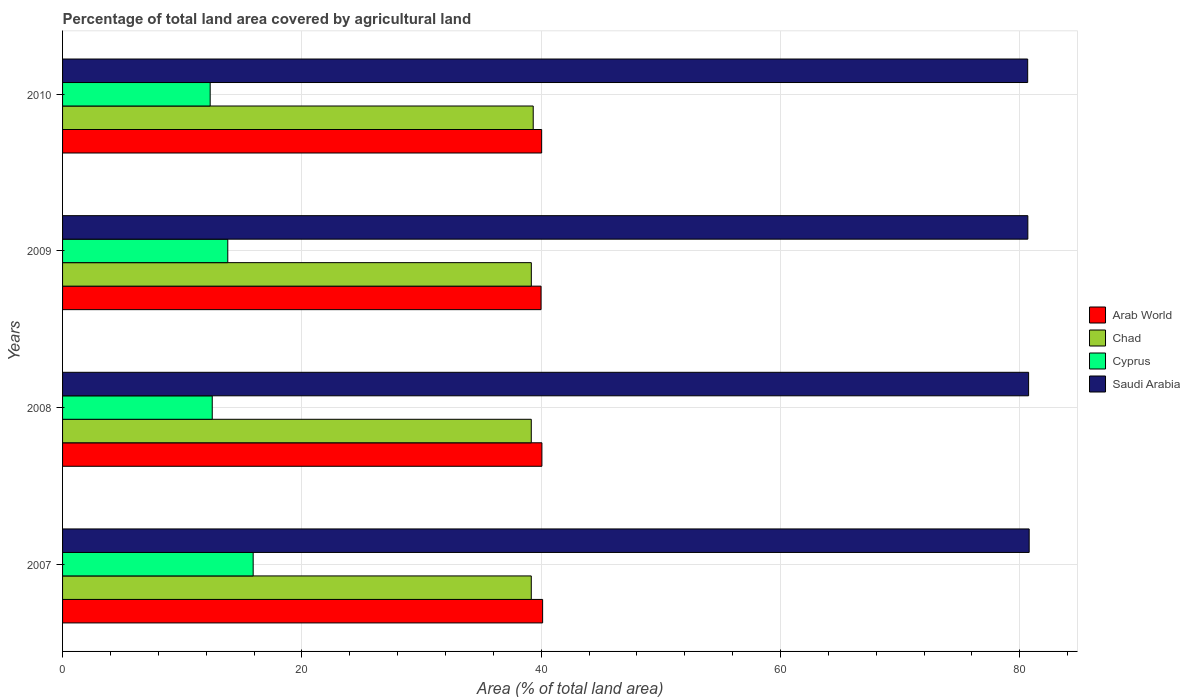How many groups of bars are there?
Give a very brief answer. 4. What is the label of the 3rd group of bars from the top?
Offer a terse response. 2008. What is the percentage of agricultural land in Cyprus in 2009?
Provide a short and direct response. 13.81. Across all years, what is the maximum percentage of agricultural land in Saudi Arabia?
Your answer should be compact. 80.79. Across all years, what is the minimum percentage of agricultural land in Saudi Arabia?
Offer a terse response. 80.67. What is the total percentage of agricultural land in Arab World in the graph?
Give a very brief answer. 160.22. What is the difference between the percentage of agricultural land in Cyprus in 2008 and that in 2010?
Ensure brevity in your answer.  0.17. What is the difference between the percentage of agricultural land in Chad in 2010 and the percentage of agricultural land in Cyprus in 2009?
Provide a succinct answer. 25.53. What is the average percentage of agricultural land in Cyprus per year?
Your answer should be very brief. 13.65. In the year 2007, what is the difference between the percentage of agricultural land in Cyprus and percentage of agricultural land in Saudi Arabia?
Make the answer very short. -64.86. What is the ratio of the percentage of agricultural land in Arab World in 2007 to that in 2009?
Offer a very short reply. 1. Is the percentage of agricultural land in Cyprus in 2007 less than that in 2010?
Ensure brevity in your answer.  No. What is the difference between the highest and the second highest percentage of agricultural land in Saudi Arabia?
Make the answer very short. 0.05. What is the difference between the highest and the lowest percentage of agricultural land in Arab World?
Provide a short and direct response. 0.13. In how many years, is the percentage of agricultural land in Saudi Arabia greater than the average percentage of agricultural land in Saudi Arabia taken over all years?
Give a very brief answer. 2. Is the sum of the percentage of agricultural land in Chad in 2009 and 2010 greater than the maximum percentage of agricultural land in Saudi Arabia across all years?
Give a very brief answer. No. What does the 1st bar from the top in 2007 represents?
Ensure brevity in your answer.  Saudi Arabia. What does the 3rd bar from the bottom in 2007 represents?
Your answer should be compact. Cyprus. Is it the case that in every year, the sum of the percentage of agricultural land in Cyprus and percentage of agricultural land in Chad is greater than the percentage of agricultural land in Saudi Arabia?
Your answer should be very brief. No. How many bars are there?
Your answer should be very brief. 16. Are all the bars in the graph horizontal?
Make the answer very short. Yes. How many legend labels are there?
Make the answer very short. 4. How are the legend labels stacked?
Your answer should be very brief. Vertical. What is the title of the graph?
Provide a succinct answer. Percentage of total land area covered by agricultural land. Does "Comoros" appear as one of the legend labels in the graph?
Your answer should be very brief. No. What is the label or title of the X-axis?
Your answer should be very brief. Area (% of total land area). What is the label or title of the Y-axis?
Make the answer very short. Years. What is the Area (% of total land area) of Arab World in 2007?
Make the answer very short. 40.12. What is the Area (% of total land area) of Chad in 2007?
Give a very brief answer. 39.18. What is the Area (% of total land area) of Cyprus in 2007?
Your answer should be very brief. 15.93. What is the Area (% of total land area) of Saudi Arabia in 2007?
Your response must be concise. 80.79. What is the Area (% of total land area) of Arab World in 2008?
Offer a terse response. 40.06. What is the Area (% of total land area) of Chad in 2008?
Your answer should be compact. 39.18. What is the Area (% of total land area) in Cyprus in 2008?
Give a very brief answer. 12.51. What is the Area (% of total land area) in Saudi Arabia in 2008?
Ensure brevity in your answer.  80.74. What is the Area (% of total land area) of Arab World in 2009?
Your answer should be compact. 39.99. What is the Area (% of total land area) in Chad in 2009?
Your answer should be very brief. 39.18. What is the Area (% of total land area) in Cyprus in 2009?
Your answer should be compact. 13.81. What is the Area (% of total land area) in Saudi Arabia in 2009?
Give a very brief answer. 80.68. What is the Area (% of total land area) of Arab World in 2010?
Your answer should be compact. 40.04. What is the Area (% of total land area) in Chad in 2010?
Give a very brief answer. 39.34. What is the Area (% of total land area) in Cyprus in 2010?
Keep it short and to the point. 12.34. What is the Area (% of total land area) of Saudi Arabia in 2010?
Your answer should be compact. 80.67. Across all years, what is the maximum Area (% of total land area) in Arab World?
Ensure brevity in your answer.  40.12. Across all years, what is the maximum Area (% of total land area) of Chad?
Give a very brief answer. 39.34. Across all years, what is the maximum Area (% of total land area) in Cyprus?
Make the answer very short. 15.93. Across all years, what is the maximum Area (% of total land area) of Saudi Arabia?
Your response must be concise. 80.79. Across all years, what is the minimum Area (% of total land area) of Arab World?
Make the answer very short. 39.99. Across all years, what is the minimum Area (% of total land area) in Chad?
Your answer should be very brief. 39.18. Across all years, what is the minimum Area (% of total land area) in Cyprus?
Provide a succinct answer. 12.34. Across all years, what is the minimum Area (% of total land area) in Saudi Arabia?
Make the answer very short. 80.67. What is the total Area (% of total land area) in Arab World in the graph?
Your response must be concise. 160.22. What is the total Area (% of total land area) in Chad in the graph?
Keep it short and to the point. 156.87. What is the total Area (% of total land area) in Cyprus in the graph?
Give a very brief answer. 54.59. What is the total Area (% of total land area) of Saudi Arabia in the graph?
Make the answer very short. 322.88. What is the difference between the Area (% of total land area) of Arab World in 2007 and that in 2008?
Your answer should be very brief. 0.06. What is the difference between the Area (% of total land area) of Cyprus in 2007 and that in 2008?
Make the answer very short. 3.42. What is the difference between the Area (% of total land area) in Saudi Arabia in 2007 and that in 2008?
Provide a succinct answer. 0.05. What is the difference between the Area (% of total land area) in Arab World in 2007 and that in 2009?
Provide a short and direct response. 0.13. What is the difference between the Area (% of total land area) in Chad in 2007 and that in 2009?
Keep it short and to the point. -0. What is the difference between the Area (% of total land area) in Cyprus in 2007 and that in 2009?
Offer a very short reply. 2.12. What is the difference between the Area (% of total land area) in Saudi Arabia in 2007 and that in 2009?
Provide a short and direct response. 0.11. What is the difference between the Area (% of total land area) of Arab World in 2007 and that in 2010?
Offer a terse response. 0.08. What is the difference between the Area (% of total land area) in Chad in 2007 and that in 2010?
Keep it short and to the point. -0.16. What is the difference between the Area (% of total land area) in Cyprus in 2007 and that in 2010?
Offer a very short reply. 3.59. What is the difference between the Area (% of total land area) in Saudi Arabia in 2007 and that in 2010?
Provide a short and direct response. 0.13. What is the difference between the Area (% of total land area) in Arab World in 2008 and that in 2009?
Offer a terse response. 0.07. What is the difference between the Area (% of total land area) in Chad in 2008 and that in 2009?
Your answer should be compact. -0. What is the difference between the Area (% of total land area) of Cyprus in 2008 and that in 2009?
Provide a short and direct response. -1.3. What is the difference between the Area (% of total land area) in Saudi Arabia in 2008 and that in 2009?
Make the answer very short. 0.06. What is the difference between the Area (% of total land area) of Arab World in 2008 and that in 2010?
Keep it short and to the point. 0.02. What is the difference between the Area (% of total land area) in Chad in 2008 and that in 2010?
Give a very brief answer. -0.16. What is the difference between the Area (% of total land area) in Cyprus in 2008 and that in 2010?
Keep it short and to the point. 0.17. What is the difference between the Area (% of total land area) in Saudi Arabia in 2008 and that in 2010?
Keep it short and to the point. 0.08. What is the difference between the Area (% of total land area) in Arab World in 2009 and that in 2010?
Ensure brevity in your answer.  -0.05. What is the difference between the Area (% of total land area) of Chad in 2009 and that in 2010?
Provide a short and direct response. -0.16. What is the difference between the Area (% of total land area) in Cyprus in 2009 and that in 2010?
Provide a short and direct response. 1.47. What is the difference between the Area (% of total land area) of Saudi Arabia in 2009 and that in 2010?
Offer a very short reply. 0.01. What is the difference between the Area (% of total land area) of Arab World in 2007 and the Area (% of total land area) of Chad in 2008?
Make the answer very short. 0.95. What is the difference between the Area (% of total land area) of Arab World in 2007 and the Area (% of total land area) of Cyprus in 2008?
Make the answer very short. 27.61. What is the difference between the Area (% of total land area) in Arab World in 2007 and the Area (% of total land area) in Saudi Arabia in 2008?
Keep it short and to the point. -40.62. What is the difference between the Area (% of total land area) in Chad in 2007 and the Area (% of total land area) in Cyprus in 2008?
Offer a very short reply. 26.67. What is the difference between the Area (% of total land area) in Chad in 2007 and the Area (% of total land area) in Saudi Arabia in 2008?
Your response must be concise. -41.57. What is the difference between the Area (% of total land area) of Cyprus in 2007 and the Area (% of total land area) of Saudi Arabia in 2008?
Your answer should be very brief. -64.81. What is the difference between the Area (% of total land area) of Arab World in 2007 and the Area (% of total land area) of Chad in 2009?
Provide a succinct answer. 0.94. What is the difference between the Area (% of total land area) in Arab World in 2007 and the Area (% of total land area) in Cyprus in 2009?
Your answer should be compact. 26.31. What is the difference between the Area (% of total land area) in Arab World in 2007 and the Area (% of total land area) in Saudi Arabia in 2009?
Your answer should be compact. -40.56. What is the difference between the Area (% of total land area) of Chad in 2007 and the Area (% of total land area) of Cyprus in 2009?
Your answer should be compact. 25.37. What is the difference between the Area (% of total land area) of Chad in 2007 and the Area (% of total land area) of Saudi Arabia in 2009?
Your answer should be compact. -41.5. What is the difference between the Area (% of total land area) in Cyprus in 2007 and the Area (% of total land area) in Saudi Arabia in 2009?
Keep it short and to the point. -64.75. What is the difference between the Area (% of total land area) in Arab World in 2007 and the Area (% of total land area) in Chad in 2010?
Your answer should be very brief. 0.79. What is the difference between the Area (% of total land area) of Arab World in 2007 and the Area (% of total land area) of Cyprus in 2010?
Provide a succinct answer. 27.79. What is the difference between the Area (% of total land area) of Arab World in 2007 and the Area (% of total land area) of Saudi Arabia in 2010?
Keep it short and to the point. -40.54. What is the difference between the Area (% of total land area) of Chad in 2007 and the Area (% of total land area) of Cyprus in 2010?
Offer a terse response. 26.84. What is the difference between the Area (% of total land area) of Chad in 2007 and the Area (% of total land area) of Saudi Arabia in 2010?
Keep it short and to the point. -41.49. What is the difference between the Area (% of total land area) of Cyprus in 2007 and the Area (% of total land area) of Saudi Arabia in 2010?
Your response must be concise. -64.73. What is the difference between the Area (% of total land area) in Arab World in 2008 and the Area (% of total land area) in Chad in 2009?
Ensure brevity in your answer.  0.88. What is the difference between the Area (% of total land area) of Arab World in 2008 and the Area (% of total land area) of Cyprus in 2009?
Your answer should be compact. 26.25. What is the difference between the Area (% of total land area) of Arab World in 2008 and the Area (% of total land area) of Saudi Arabia in 2009?
Keep it short and to the point. -40.62. What is the difference between the Area (% of total land area) in Chad in 2008 and the Area (% of total land area) in Cyprus in 2009?
Offer a terse response. 25.37. What is the difference between the Area (% of total land area) in Chad in 2008 and the Area (% of total land area) in Saudi Arabia in 2009?
Ensure brevity in your answer.  -41.5. What is the difference between the Area (% of total land area) of Cyprus in 2008 and the Area (% of total land area) of Saudi Arabia in 2009?
Your answer should be very brief. -68.17. What is the difference between the Area (% of total land area) of Arab World in 2008 and the Area (% of total land area) of Chad in 2010?
Your answer should be very brief. 0.72. What is the difference between the Area (% of total land area) in Arab World in 2008 and the Area (% of total land area) in Cyprus in 2010?
Your answer should be very brief. 27.73. What is the difference between the Area (% of total land area) in Arab World in 2008 and the Area (% of total land area) in Saudi Arabia in 2010?
Offer a terse response. -40.6. What is the difference between the Area (% of total land area) in Chad in 2008 and the Area (% of total land area) in Cyprus in 2010?
Your response must be concise. 26.84. What is the difference between the Area (% of total land area) in Chad in 2008 and the Area (% of total land area) in Saudi Arabia in 2010?
Provide a succinct answer. -41.49. What is the difference between the Area (% of total land area) in Cyprus in 2008 and the Area (% of total land area) in Saudi Arabia in 2010?
Provide a succinct answer. -68.15. What is the difference between the Area (% of total land area) in Arab World in 2009 and the Area (% of total land area) in Chad in 2010?
Keep it short and to the point. 0.65. What is the difference between the Area (% of total land area) in Arab World in 2009 and the Area (% of total land area) in Cyprus in 2010?
Your answer should be very brief. 27.66. What is the difference between the Area (% of total land area) in Arab World in 2009 and the Area (% of total land area) in Saudi Arabia in 2010?
Your answer should be compact. -40.67. What is the difference between the Area (% of total land area) of Chad in 2009 and the Area (% of total land area) of Cyprus in 2010?
Make the answer very short. 26.84. What is the difference between the Area (% of total land area) in Chad in 2009 and the Area (% of total land area) in Saudi Arabia in 2010?
Offer a very short reply. -41.49. What is the difference between the Area (% of total land area) in Cyprus in 2009 and the Area (% of total land area) in Saudi Arabia in 2010?
Your answer should be very brief. -66.86. What is the average Area (% of total land area) in Arab World per year?
Provide a succinct answer. 40.06. What is the average Area (% of total land area) of Chad per year?
Give a very brief answer. 39.22. What is the average Area (% of total land area) of Cyprus per year?
Ensure brevity in your answer.  13.65. What is the average Area (% of total land area) of Saudi Arabia per year?
Your answer should be compact. 80.72. In the year 2007, what is the difference between the Area (% of total land area) of Arab World and Area (% of total land area) of Chad?
Offer a very short reply. 0.95. In the year 2007, what is the difference between the Area (% of total land area) in Arab World and Area (% of total land area) in Cyprus?
Keep it short and to the point. 24.19. In the year 2007, what is the difference between the Area (% of total land area) in Arab World and Area (% of total land area) in Saudi Arabia?
Provide a short and direct response. -40.67. In the year 2007, what is the difference between the Area (% of total land area) in Chad and Area (% of total land area) in Cyprus?
Your response must be concise. 23.25. In the year 2007, what is the difference between the Area (% of total land area) of Chad and Area (% of total land area) of Saudi Arabia?
Provide a short and direct response. -41.61. In the year 2007, what is the difference between the Area (% of total land area) of Cyprus and Area (% of total land area) of Saudi Arabia?
Ensure brevity in your answer.  -64.86. In the year 2008, what is the difference between the Area (% of total land area) of Arab World and Area (% of total land area) of Chad?
Offer a very short reply. 0.89. In the year 2008, what is the difference between the Area (% of total land area) in Arab World and Area (% of total land area) in Cyprus?
Make the answer very short. 27.55. In the year 2008, what is the difference between the Area (% of total land area) in Arab World and Area (% of total land area) in Saudi Arabia?
Make the answer very short. -40.68. In the year 2008, what is the difference between the Area (% of total land area) in Chad and Area (% of total land area) in Cyprus?
Give a very brief answer. 26.67. In the year 2008, what is the difference between the Area (% of total land area) of Chad and Area (% of total land area) of Saudi Arabia?
Make the answer very short. -41.57. In the year 2008, what is the difference between the Area (% of total land area) of Cyprus and Area (% of total land area) of Saudi Arabia?
Provide a succinct answer. -68.23. In the year 2009, what is the difference between the Area (% of total land area) in Arab World and Area (% of total land area) in Chad?
Provide a succinct answer. 0.81. In the year 2009, what is the difference between the Area (% of total land area) of Arab World and Area (% of total land area) of Cyprus?
Keep it short and to the point. 26.18. In the year 2009, what is the difference between the Area (% of total land area) of Arab World and Area (% of total land area) of Saudi Arabia?
Offer a very short reply. -40.69. In the year 2009, what is the difference between the Area (% of total land area) in Chad and Area (% of total land area) in Cyprus?
Offer a terse response. 25.37. In the year 2009, what is the difference between the Area (% of total land area) of Chad and Area (% of total land area) of Saudi Arabia?
Offer a terse response. -41.5. In the year 2009, what is the difference between the Area (% of total land area) in Cyprus and Area (% of total land area) in Saudi Arabia?
Your response must be concise. -66.87. In the year 2010, what is the difference between the Area (% of total land area) of Arab World and Area (% of total land area) of Chad?
Offer a terse response. 0.7. In the year 2010, what is the difference between the Area (% of total land area) in Arab World and Area (% of total land area) in Cyprus?
Provide a succinct answer. 27.71. In the year 2010, what is the difference between the Area (% of total land area) of Arab World and Area (% of total land area) of Saudi Arabia?
Provide a short and direct response. -40.62. In the year 2010, what is the difference between the Area (% of total land area) of Chad and Area (% of total land area) of Cyprus?
Ensure brevity in your answer.  27. In the year 2010, what is the difference between the Area (% of total land area) of Chad and Area (% of total land area) of Saudi Arabia?
Offer a very short reply. -41.33. In the year 2010, what is the difference between the Area (% of total land area) in Cyprus and Area (% of total land area) in Saudi Arabia?
Provide a succinct answer. -68.33. What is the ratio of the Area (% of total land area) in Chad in 2007 to that in 2008?
Your response must be concise. 1. What is the ratio of the Area (% of total land area) in Cyprus in 2007 to that in 2008?
Your answer should be very brief. 1.27. What is the ratio of the Area (% of total land area) of Saudi Arabia in 2007 to that in 2008?
Your answer should be compact. 1. What is the ratio of the Area (% of total land area) of Arab World in 2007 to that in 2009?
Your answer should be very brief. 1. What is the ratio of the Area (% of total land area) of Cyprus in 2007 to that in 2009?
Make the answer very short. 1.15. What is the ratio of the Area (% of total land area) in Cyprus in 2007 to that in 2010?
Keep it short and to the point. 1.29. What is the ratio of the Area (% of total land area) in Chad in 2008 to that in 2009?
Make the answer very short. 1. What is the ratio of the Area (% of total land area) in Cyprus in 2008 to that in 2009?
Your answer should be compact. 0.91. What is the ratio of the Area (% of total land area) in Saudi Arabia in 2008 to that in 2010?
Make the answer very short. 1. What is the ratio of the Area (% of total land area) of Cyprus in 2009 to that in 2010?
Ensure brevity in your answer.  1.12. What is the ratio of the Area (% of total land area) in Saudi Arabia in 2009 to that in 2010?
Provide a short and direct response. 1. What is the difference between the highest and the second highest Area (% of total land area) of Chad?
Keep it short and to the point. 0.16. What is the difference between the highest and the second highest Area (% of total land area) of Cyprus?
Your answer should be compact. 2.12. What is the difference between the highest and the second highest Area (% of total land area) in Saudi Arabia?
Provide a succinct answer. 0.05. What is the difference between the highest and the lowest Area (% of total land area) of Arab World?
Give a very brief answer. 0.13. What is the difference between the highest and the lowest Area (% of total land area) in Chad?
Provide a succinct answer. 0.16. What is the difference between the highest and the lowest Area (% of total land area) of Cyprus?
Make the answer very short. 3.59. What is the difference between the highest and the lowest Area (% of total land area) of Saudi Arabia?
Provide a succinct answer. 0.13. 